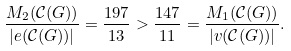Convert formula to latex. <formula><loc_0><loc_0><loc_500><loc_500>\frac { M _ { 2 } ( \mathcal { C } ( G ) ) } { | e ( \mathcal { C } ( G ) ) | } = \frac { 1 9 7 } { 1 3 } > \frac { 1 4 7 } { 1 1 } = \frac { M _ { 1 } ( \mathcal { C } ( G ) ) } { | v ( \mathcal { C } ( G ) ) | } .</formula> 